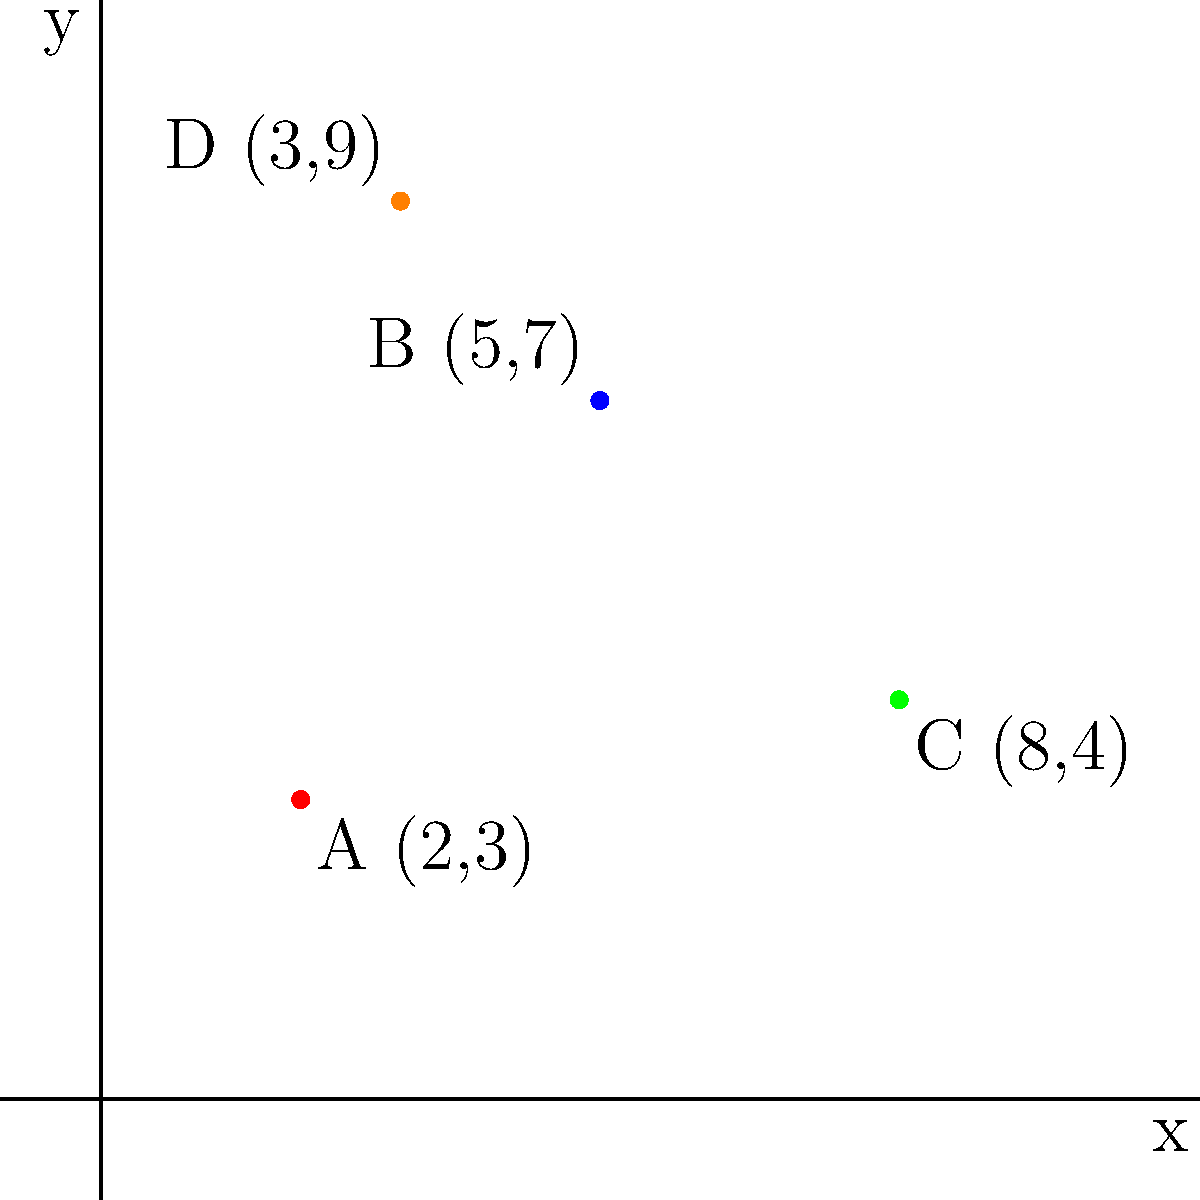On the coordinate plane above, four significant events from your life as an author are plotted:
A (2,3): Publication of your first novel
B (5,7): Winning a prestigious literary award
C (8,4): Release of your bestselling memoir
D (3,9): Your first international book tour

Calculate the distance between the points representing your first novel publication (A) and your bestselling memoir release (C). To find the distance between two points on a coordinate plane, we use the distance formula:

$$d = \sqrt{(x_2 - x_1)^2 + (y_2 - y_1)^2}$$

Where $(x_1, y_1)$ are the coordinates of the first point and $(x_2, y_2)$ are the coordinates of the second point.

Step 1: Identify the coordinates
Point A (first novel): $(x_1, y_1) = (2, 3)$
Point C (bestselling memoir): $(x_2, y_2) = (8, 4)$

Step 2: Plug the values into the distance formula
$$d = \sqrt{(8 - 2)^2 + (4 - 3)^2}$$

Step 3: Simplify
$$d = \sqrt{6^2 + 1^2}$$
$$d = \sqrt{36 + 1}$$
$$d = \sqrt{37}$$

Step 4: Simplify the square root (if needed)
The square root of 37 cannot be simplified further, so we leave it as $\sqrt{37}$.

Therefore, the distance between the publication of your first novel and the release of your bestselling memoir is $\sqrt{37}$ units on the coordinate plane.
Answer: $\sqrt{37}$ units 